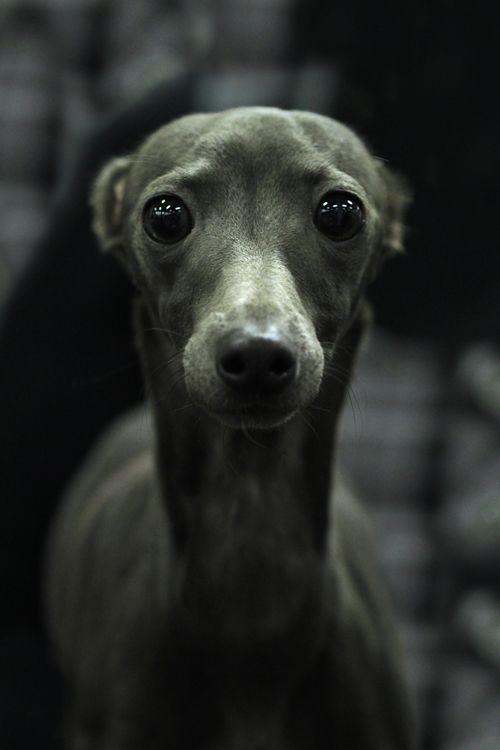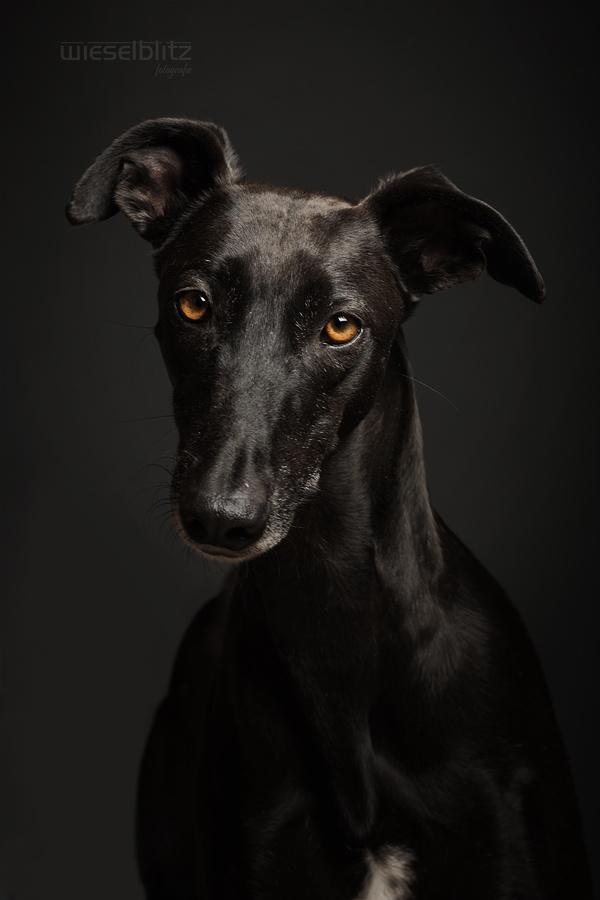The first image is the image on the left, the second image is the image on the right. Given the left and right images, does the statement "There is grass visible in one of the images." hold true? Answer yes or no. No. The first image is the image on the left, the second image is the image on the right. Analyze the images presented: Is the assertion "One dog is in grass." valid? Answer yes or no. No. 